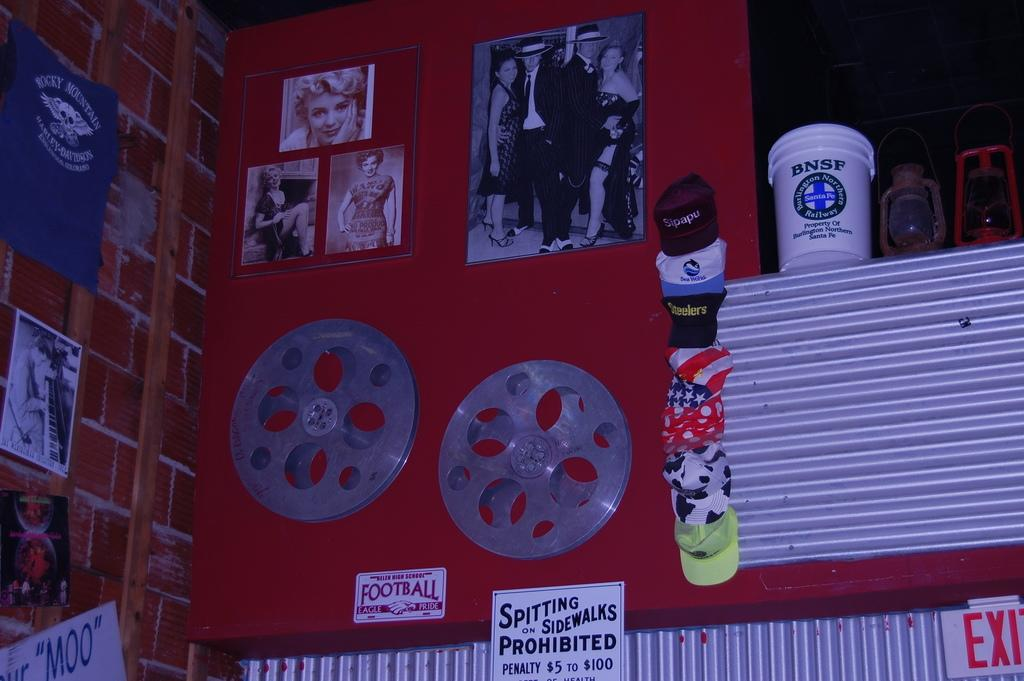<image>
Provide a brief description of the given image. A wall of vintage items includes a sign prohibiting spitting on sidewalks. 